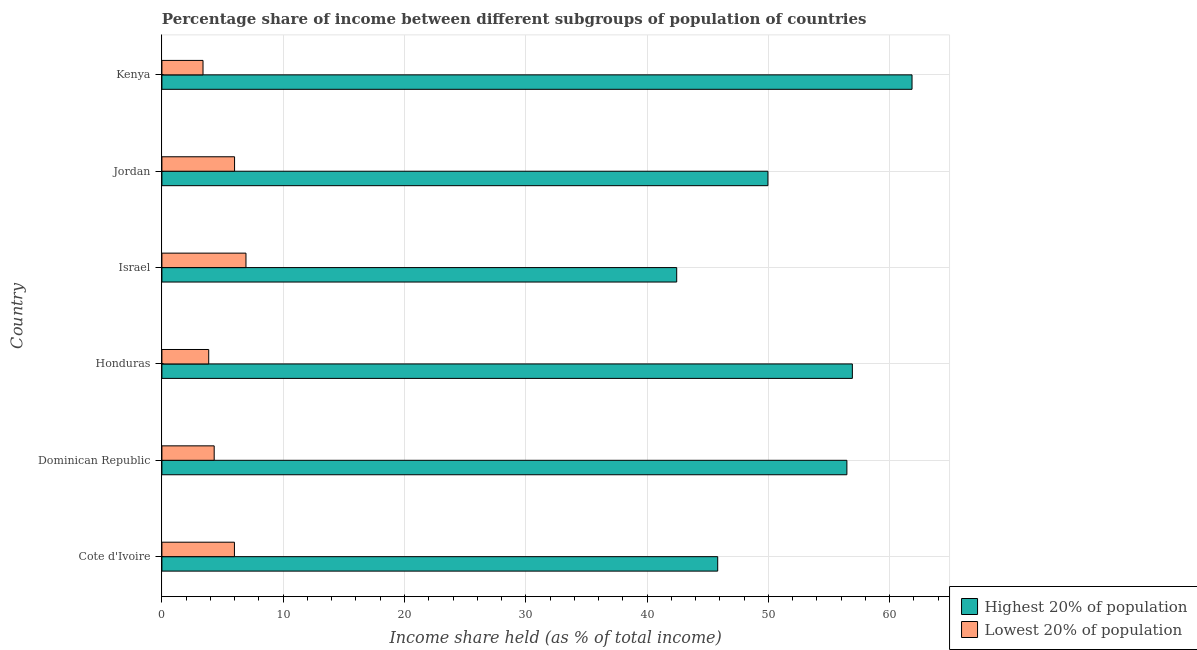How many different coloured bars are there?
Your answer should be very brief. 2. Are the number of bars on each tick of the Y-axis equal?
Your answer should be compact. Yes. How many bars are there on the 4th tick from the top?
Keep it short and to the point. 2. How many bars are there on the 1st tick from the bottom?
Your answer should be very brief. 2. What is the label of the 4th group of bars from the top?
Keep it short and to the point. Honduras. In how many cases, is the number of bars for a given country not equal to the number of legend labels?
Provide a short and direct response. 0. What is the income share held by lowest 20% of the population in Jordan?
Offer a terse response. 5.99. Across all countries, what is the maximum income share held by lowest 20% of the population?
Offer a very short reply. 6.93. Across all countries, what is the minimum income share held by lowest 20% of the population?
Provide a succinct answer. 3.39. In which country was the income share held by highest 20% of the population maximum?
Your answer should be compact. Kenya. In which country was the income share held by lowest 20% of the population minimum?
Your answer should be compact. Kenya. What is the total income share held by highest 20% of the population in the graph?
Keep it short and to the point. 313.45. What is the difference between the income share held by highest 20% of the population in Honduras and that in Kenya?
Offer a terse response. -4.92. What is the difference between the income share held by highest 20% of the population in Kenya and the income share held by lowest 20% of the population in Dominican Republic?
Your answer should be very brief. 57.53. What is the average income share held by highest 20% of the population per country?
Provide a short and direct response. 52.24. What is the difference between the income share held by highest 20% of the population and income share held by lowest 20% of the population in Kenya?
Give a very brief answer. 58.45. In how many countries, is the income share held by highest 20% of the population greater than 22 %?
Offer a terse response. 6. What is the ratio of the income share held by highest 20% of the population in Cote d'Ivoire to that in Israel?
Keep it short and to the point. 1.08. Is the income share held by lowest 20% of the population in Israel less than that in Kenya?
Offer a terse response. No. Is the difference between the income share held by lowest 20% of the population in Dominican Republic and Kenya greater than the difference between the income share held by highest 20% of the population in Dominican Republic and Kenya?
Offer a terse response. Yes. What is the difference between the highest and the second highest income share held by highest 20% of the population?
Your response must be concise. 4.92. What is the difference between the highest and the lowest income share held by lowest 20% of the population?
Ensure brevity in your answer.  3.54. In how many countries, is the income share held by highest 20% of the population greater than the average income share held by highest 20% of the population taken over all countries?
Ensure brevity in your answer.  3. What does the 2nd bar from the top in Jordan represents?
Keep it short and to the point. Highest 20% of population. What does the 1st bar from the bottom in Dominican Republic represents?
Your response must be concise. Highest 20% of population. Are all the bars in the graph horizontal?
Provide a short and direct response. Yes. How many countries are there in the graph?
Your answer should be very brief. 6. What is the difference between two consecutive major ticks on the X-axis?
Your answer should be very brief. 10. Does the graph contain grids?
Offer a very short reply. Yes. Where does the legend appear in the graph?
Offer a very short reply. Bottom right. How many legend labels are there?
Make the answer very short. 2. What is the title of the graph?
Ensure brevity in your answer.  Percentage share of income between different subgroups of population of countries. Does "By country of origin" appear as one of the legend labels in the graph?
Keep it short and to the point. No. What is the label or title of the X-axis?
Ensure brevity in your answer.  Income share held (as % of total income). What is the label or title of the Y-axis?
Keep it short and to the point. Country. What is the Income share held (as % of total income) of Highest 20% of population in Cote d'Ivoire?
Ensure brevity in your answer.  45.82. What is the Income share held (as % of total income) of Lowest 20% of population in Cote d'Ivoire?
Ensure brevity in your answer.  5.98. What is the Income share held (as % of total income) in Highest 20% of population in Dominican Republic?
Provide a succinct answer. 56.47. What is the Income share held (as % of total income) in Lowest 20% of population in Dominican Republic?
Your answer should be very brief. 4.31. What is the Income share held (as % of total income) of Highest 20% of population in Honduras?
Keep it short and to the point. 56.92. What is the Income share held (as % of total income) of Lowest 20% of population in Honduras?
Your answer should be very brief. 3.86. What is the Income share held (as % of total income) in Highest 20% of population in Israel?
Offer a very short reply. 42.44. What is the Income share held (as % of total income) of Lowest 20% of population in Israel?
Offer a very short reply. 6.93. What is the Income share held (as % of total income) in Highest 20% of population in Jordan?
Make the answer very short. 49.96. What is the Income share held (as % of total income) of Lowest 20% of population in Jordan?
Provide a succinct answer. 5.99. What is the Income share held (as % of total income) of Highest 20% of population in Kenya?
Provide a succinct answer. 61.84. What is the Income share held (as % of total income) in Lowest 20% of population in Kenya?
Provide a succinct answer. 3.39. Across all countries, what is the maximum Income share held (as % of total income) of Highest 20% of population?
Your response must be concise. 61.84. Across all countries, what is the maximum Income share held (as % of total income) in Lowest 20% of population?
Provide a succinct answer. 6.93. Across all countries, what is the minimum Income share held (as % of total income) of Highest 20% of population?
Your answer should be compact. 42.44. Across all countries, what is the minimum Income share held (as % of total income) in Lowest 20% of population?
Your answer should be compact. 3.39. What is the total Income share held (as % of total income) in Highest 20% of population in the graph?
Provide a short and direct response. 313.45. What is the total Income share held (as % of total income) of Lowest 20% of population in the graph?
Offer a terse response. 30.46. What is the difference between the Income share held (as % of total income) in Highest 20% of population in Cote d'Ivoire and that in Dominican Republic?
Your answer should be compact. -10.65. What is the difference between the Income share held (as % of total income) in Lowest 20% of population in Cote d'Ivoire and that in Dominican Republic?
Offer a very short reply. 1.67. What is the difference between the Income share held (as % of total income) in Highest 20% of population in Cote d'Ivoire and that in Honduras?
Give a very brief answer. -11.1. What is the difference between the Income share held (as % of total income) in Lowest 20% of population in Cote d'Ivoire and that in Honduras?
Your answer should be compact. 2.12. What is the difference between the Income share held (as % of total income) of Highest 20% of population in Cote d'Ivoire and that in Israel?
Your response must be concise. 3.38. What is the difference between the Income share held (as % of total income) in Lowest 20% of population in Cote d'Ivoire and that in Israel?
Provide a succinct answer. -0.95. What is the difference between the Income share held (as % of total income) in Highest 20% of population in Cote d'Ivoire and that in Jordan?
Give a very brief answer. -4.14. What is the difference between the Income share held (as % of total income) in Lowest 20% of population in Cote d'Ivoire and that in Jordan?
Ensure brevity in your answer.  -0.01. What is the difference between the Income share held (as % of total income) of Highest 20% of population in Cote d'Ivoire and that in Kenya?
Provide a short and direct response. -16.02. What is the difference between the Income share held (as % of total income) in Lowest 20% of population in Cote d'Ivoire and that in Kenya?
Give a very brief answer. 2.59. What is the difference between the Income share held (as % of total income) in Highest 20% of population in Dominican Republic and that in Honduras?
Your response must be concise. -0.45. What is the difference between the Income share held (as % of total income) of Lowest 20% of population in Dominican Republic and that in Honduras?
Provide a short and direct response. 0.45. What is the difference between the Income share held (as % of total income) in Highest 20% of population in Dominican Republic and that in Israel?
Give a very brief answer. 14.03. What is the difference between the Income share held (as % of total income) in Lowest 20% of population in Dominican Republic and that in Israel?
Your answer should be compact. -2.62. What is the difference between the Income share held (as % of total income) in Highest 20% of population in Dominican Republic and that in Jordan?
Your answer should be compact. 6.51. What is the difference between the Income share held (as % of total income) of Lowest 20% of population in Dominican Republic and that in Jordan?
Ensure brevity in your answer.  -1.68. What is the difference between the Income share held (as % of total income) in Highest 20% of population in Dominican Republic and that in Kenya?
Provide a succinct answer. -5.37. What is the difference between the Income share held (as % of total income) in Lowest 20% of population in Dominican Republic and that in Kenya?
Offer a terse response. 0.92. What is the difference between the Income share held (as % of total income) of Highest 20% of population in Honduras and that in Israel?
Give a very brief answer. 14.48. What is the difference between the Income share held (as % of total income) in Lowest 20% of population in Honduras and that in Israel?
Give a very brief answer. -3.07. What is the difference between the Income share held (as % of total income) in Highest 20% of population in Honduras and that in Jordan?
Offer a very short reply. 6.96. What is the difference between the Income share held (as % of total income) of Lowest 20% of population in Honduras and that in Jordan?
Give a very brief answer. -2.13. What is the difference between the Income share held (as % of total income) in Highest 20% of population in Honduras and that in Kenya?
Give a very brief answer. -4.92. What is the difference between the Income share held (as % of total income) of Lowest 20% of population in Honduras and that in Kenya?
Ensure brevity in your answer.  0.47. What is the difference between the Income share held (as % of total income) of Highest 20% of population in Israel and that in Jordan?
Make the answer very short. -7.52. What is the difference between the Income share held (as % of total income) in Highest 20% of population in Israel and that in Kenya?
Offer a very short reply. -19.4. What is the difference between the Income share held (as % of total income) of Lowest 20% of population in Israel and that in Kenya?
Keep it short and to the point. 3.54. What is the difference between the Income share held (as % of total income) of Highest 20% of population in Jordan and that in Kenya?
Provide a short and direct response. -11.88. What is the difference between the Income share held (as % of total income) of Lowest 20% of population in Jordan and that in Kenya?
Offer a terse response. 2.6. What is the difference between the Income share held (as % of total income) of Highest 20% of population in Cote d'Ivoire and the Income share held (as % of total income) of Lowest 20% of population in Dominican Republic?
Keep it short and to the point. 41.51. What is the difference between the Income share held (as % of total income) in Highest 20% of population in Cote d'Ivoire and the Income share held (as % of total income) in Lowest 20% of population in Honduras?
Give a very brief answer. 41.96. What is the difference between the Income share held (as % of total income) in Highest 20% of population in Cote d'Ivoire and the Income share held (as % of total income) in Lowest 20% of population in Israel?
Give a very brief answer. 38.89. What is the difference between the Income share held (as % of total income) in Highest 20% of population in Cote d'Ivoire and the Income share held (as % of total income) in Lowest 20% of population in Jordan?
Your answer should be very brief. 39.83. What is the difference between the Income share held (as % of total income) in Highest 20% of population in Cote d'Ivoire and the Income share held (as % of total income) in Lowest 20% of population in Kenya?
Provide a succinct answer. 42.43. What is the difference between the Income share held (as % of total income) in Highest 20% of population in Dominican Republic and the Income share held (as % of total income) in Lowest 20% of population in Honduras?
Your answer should be compact. 52.61. What is the difference between the Income share held (as % of total income) of Highest 20% of population in Dominican Republic and the Income share held (as % of total income) of Lowest 20% of population in Israel?
Give a very brief answer. 49.54. What is the difference between the Income share held (as % of total income) of Highest 20% of population in Dominican Republic and the Income share held (as % of total income) of Lowest 20% of population in Jordan?
Your answer should be compact. 50.48. What is the difference between the Income share held (as % of total income) in Highest 20% of population in Dominican Republic and the Income share held (as % of total income) in Lowest 20% of population in Kenya?
Your response must be concise. 53.08. What is the difference between the Income share held (as % of total income) of Highest 20% of population in Honduras and the Income share held (as % of total income) of Lowest 20% of population in Israel?
Offer a terse response. 49.99. What is the difference between the Income share held (as % of total income) of Highest 20% of population in Honduras and the Income share held (as % of total income) of Lowest 20% of population in Jordan?
Provide a short and direct response. 50.93. What is the difference between the Income share held (as % of total income) in Highest 20% of population in Honduras and the Income share held (as % of total income) in Lowest 20% of population in Kenya?
Offer a terse response. 53.53. What is the difference between the Income share held (as % of total income) of Highest 20% of population in Israel and the Income share held (as % of total income) of Lowest 20% of population in Jordan?
Provide a succinct answer. 36.45. What is the difference between the Income share held (as % of total income) in Highest 20% of population in Israel and the Income share held (as % of total income) in Lowest 20% of population in Kenya?
Keep it short and to the point. 39.05. What is the difference between the Income share held (as % of total income) in Highest 20% of population in Jordan and the Income share held (as % of total income) in Lowest 20% of population in Kenya?
Keep it short and to the point. 46.57. What is the average Income share held (as % of total income) of Highest 20% of population per country?
Your answer should be compact. 52.24. What is the average Income share held (as % of total income) in Lowest 20% of population per country?
Your answer should be compact. 5.08. What is the difference between the Income share held (as % of total income) of Highest 20% of population and Income share held (as % of total income) of Lowest 20% of population in Cote d'Ivoire?
Offer a very short reply. 39.84. What is the difference between the Income share held (as % of total income) in Highest 20% of population and Income share held (as % of total income) in Lowest 20% of population in Dominican Republic?
Your response must be concise. 52.16. What is the difference between the Income share held (as % of total income) of Highest 20% of population and Income share held (as % of total income) of Lowest 20% of population in Honduras?
Your answer should be compact. 53.06. What is the difference between the Income share held (as % of total income) of Highest 20% of population and Income share held (as % of total income) of Lowest 20% of population in Israel?
Your response must be concise. 35.51. What is the difference between the Income share held (as % of total income) of Highest 20% of population and Income share held (as % of total income) of Lowest 20% of population in Jordan?
Give a very brief answer. 43.97. What is the difference between the Income share held (as % of total income) of Highest 20% of population and Income share held (as % of total income) of Lowest 20% of population in Kenya?
Your answer should be very brief. 58.45. What is the ratio of the Income share held (as % of total income) in Highest 20% of population in Cote d'Ivoire to that in Dominican Republic?
Your answer should be very brief. 0.81. What is the ratio of the Income share held (as % of total income) of Lowest 20% of population in Cote d'Ivoire to that in Dominican Republic?
Give a very brief answer. 1.39. What is the ratio of the Income share held (as % of total income) of Highest 20% of population in Cote d'Ivoire to that in Honduras?
Your answer should be very brief. 0.81. What is the ratio of the Income share held (as % of total income) of Lowest 20% of population in Cote d'Ivoire to that in Honduras?
Keep it short and to the point. 1.55. What is the ratio of the Income share held (as % of total income) of Highest 20% of population in Cote d'Ivoire to that in Israel?
Your answer should be compact. 1.08. What is the ratio of the Income share held (as % of total income) of Lowest 20% of population in Cote d'Ivoire to that in Israel?
Offer a very short reply. 0.86. What is the ratio of the Income share held (as % of total income) of Highest 20% of population in Cote d'Ivoire to that in Jordan?
Keep it short and to the point. 0.92. What is the ratio of the Income share held (as % of total income) in Lowest 20% of population in Cote d'Ivoire to that in Jordan?
Your answer should be compact. 1. What is the ratio of the Income share held (as % of total income) of Highest 20% of population in Cote d'Ivoire to that in Kenya?
Keep it short and to the point. 0.74. What is the ratio of the Income share held (as % of total income) of Lowest 20% of population in Cote d'Ivoire to that in Kenya?
Your answer should be very brief. 1.76. What is the ratio of the Income share held (as % of total income) in Lowest 20% of population in Dominican Republic to that in Honduras?
Offer a terse response. 1.12. What is the ratio of the Income share held (as % of total income) in Highest 20% of population in Dominican Republic to that in Israel?
Offer a terse response. 1.33. What is the ratio of the Income share held (as % of total income) of Lowest 20% of population in Dominican Republic to that in Israel?
Offer a terse response. 0.62. What is the ratio of the Income share held (as % of total income) of Highest 20% of population in Dominican Republic to that in Jordan?
Offer a very short reply. 1.13. What is the ratio of the Income share held (as % of total income) of Lowest 20% of population in Dominican Republic to that in Jordan?
Provide a short and direct response. 0.72. What is the ratio of the Income share held (as % of total income) in Highest 20% of population in Dominican Republic to that in Kenya?
Your answer should be compact. 0.91. What is the ratio of the Income share held (as % of total income) in Lowest 20% of population in Dominican Republic to that in Kenya?
Your answer should be compact. 1.27. What is the ratio of the Income share held (as % of total income) of Highest 20% of population in Honduras to that in Israel?
Offer a terse response. 1.34. What is the ratio of the Income share held (as % of total income) in Lowest 20% of population in Honduras to that in Israel?
Offer a terse response. 0.56. What is the ratio of the Income share held (as % of total income) of Highest 20% of population in Honduras to that in Jordan?
Offer a terse response. 1.14. What is the ratio of the Income share held (as % of total income) in Lowest 20% of population in Honduras to that in Jordan?
Your answer should be compact. 0.64. What is the ratio of the Income share held (as % of total income) in Highest 20% of population in Honduras to that in Kenya?
Offer a terse response. 0.92. What is the ratio of the Income share held (as % of total income) of Lowest 20% of population in Honduras to that in Kenya?
Your answer should be very brief. 1.14. What is the ratio of the Income share held (as % of total income) in Highest 20% of population in Israel to that in Jordan?
Give a very brief answer. 0.85. What is the ratio of the Income share held (as % of total income) in Lowest 20% of population in Israel to that in Jordan?
Ensure brevity in your answer.  1.16. What is the ratio of the Income share held (as % of total income) of Highest 20% of population in Israel to that in Kenya?
Give a very brief answer. 0.69. What is the ratio of the Income share held (as % of total income) in Lowest 20% of population in Israel to that in Kenya?
Offer a very short reply. 2.04. What is the ratio of the Income share held (as % of total income) in Highest 20% of population in Jordan to that in Kenya?
Provide a succinct answer. 0.81. What is the ratio of the Income share held (as % of total income) in Lowest 20% of population in Jordan to that in Kenya?
Your answer should be very brief. 1.77. What is the difference between the highest and the second highest Income share held (as % of total income) in Highest 20% of population?
Your answer should be very brief. 4.92. What is the difference between the highest and the lowest Income share held (as % of total income) in Highest 20% of population?
Your answer should be compact. 19.4. What is the difference between the highest and the lowest Income share held (as % of total income) of Lowest 20% of population?
Make the answer very short. 3.54. 